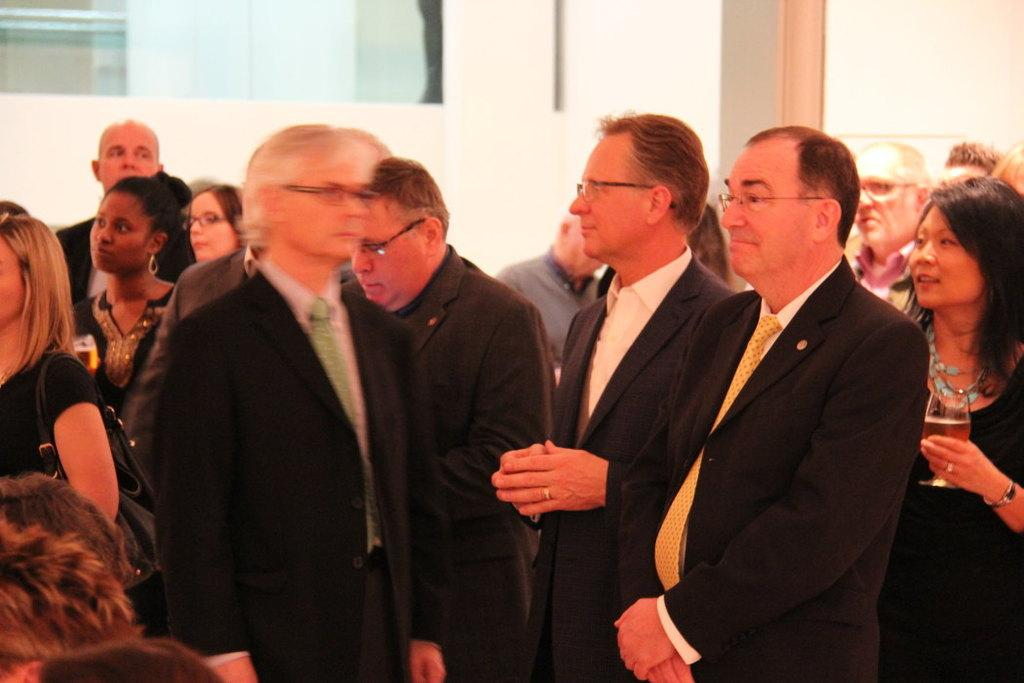Who or what can be seen in the image? There are people in the image. What is visible in the background of the image? There is a wall and glass in the background of the image. What type of finger can be seen on the wall in the image? There is no finger present on the wall in the image. 